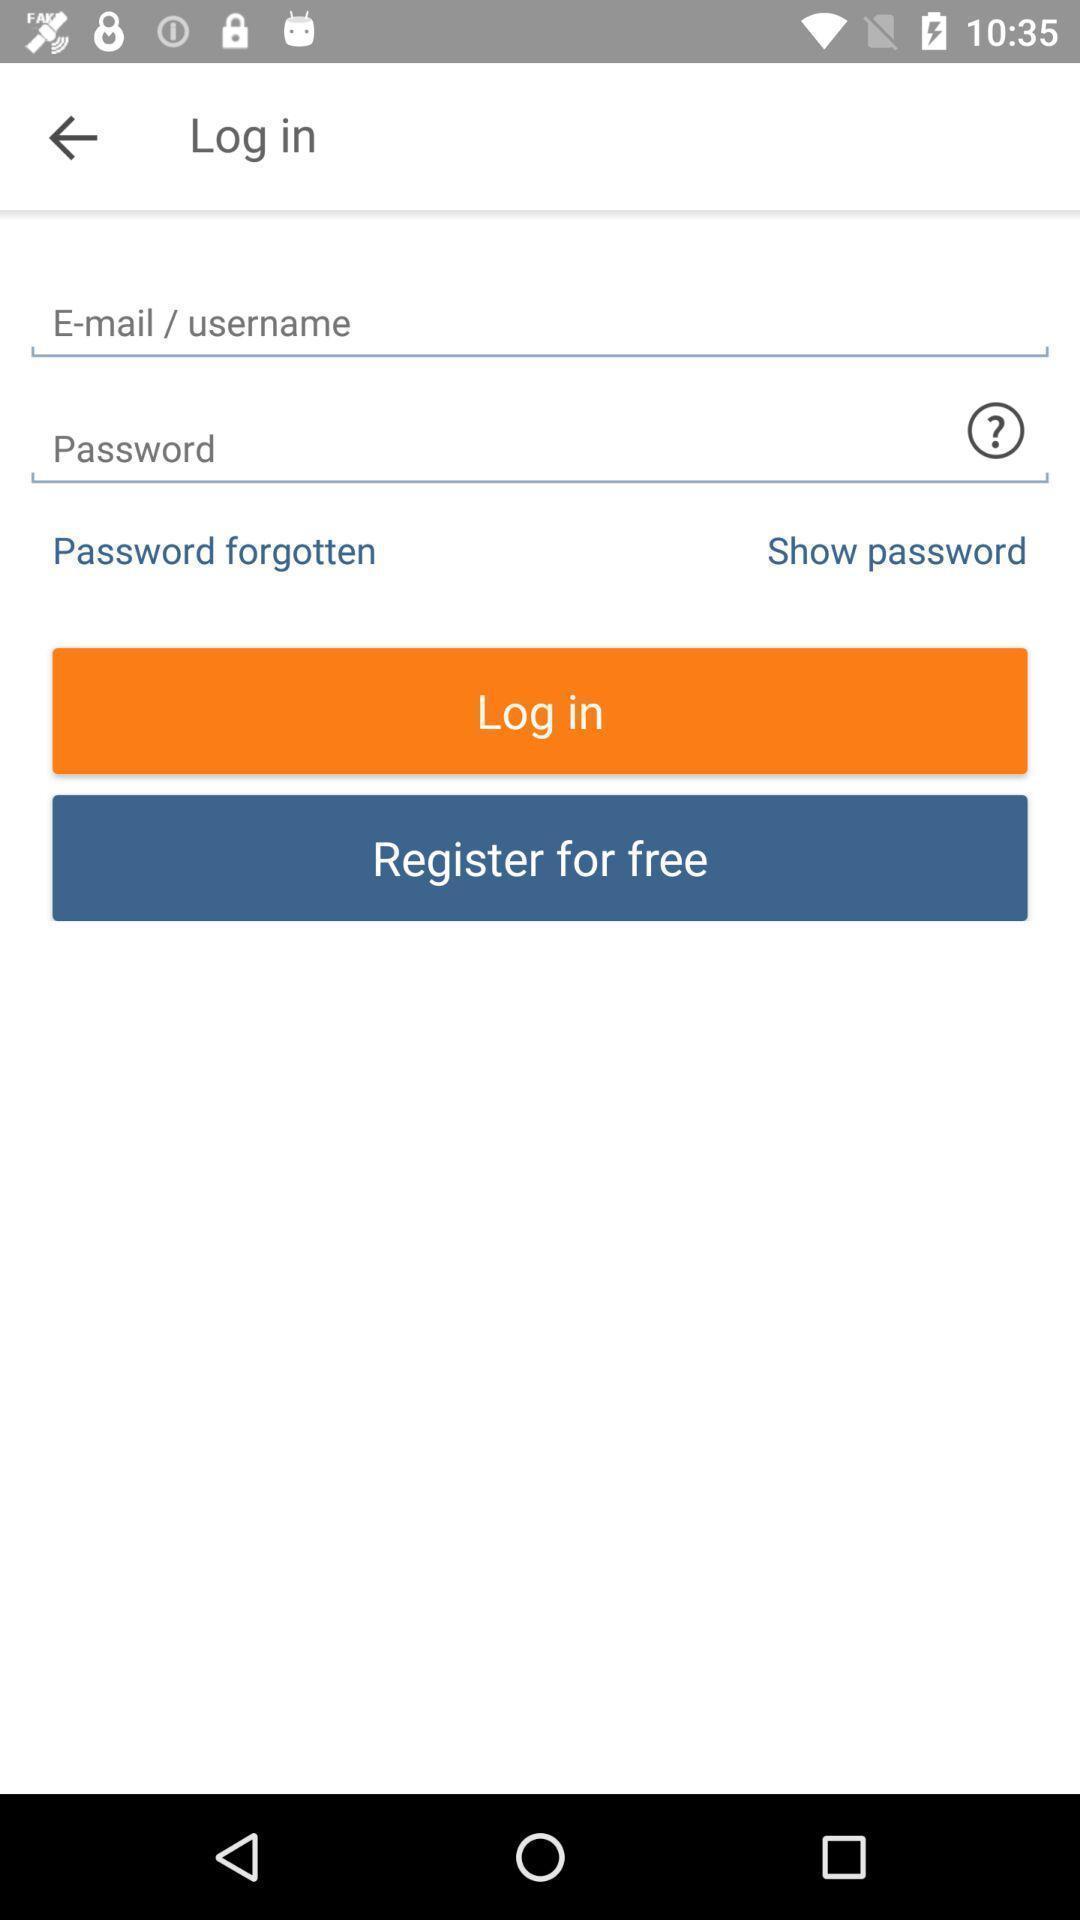Tell me about the visual elements in this screen capture. Screen displaying the login page. 